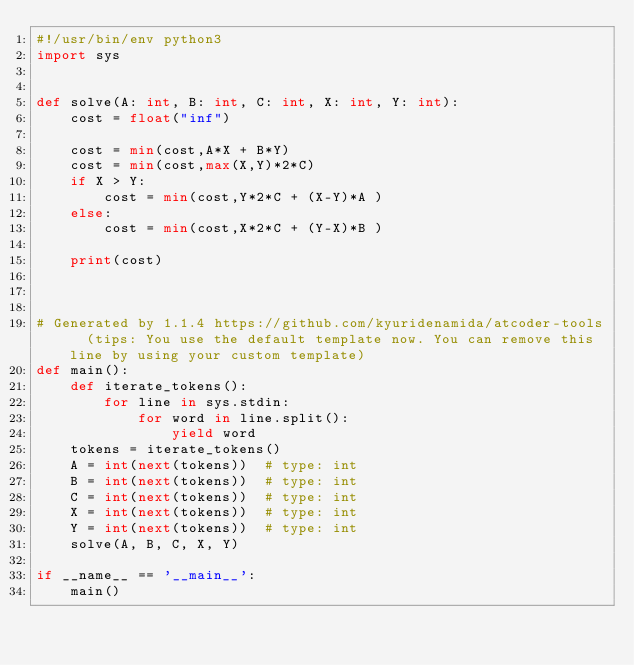<code> <loc_0><loc_0><loc_500><loc_500><_Python_>#!/usr/bin/env python3
import sys


def solve(A: int, B: int, C: int, X: int, Y: int):
    cost = float("inf")

    cost = min(cost,A*X + B*Y)
    cost = min(cost,max(X,Y)*2*C)
    if X > Y:
        cost = min(cost,Y*2*C + (X-Y)*A )
    else:
        cost = min(cost,X*2*C + (Y-X)*B )

    print(cost)



# Generated by 1.1.4 https://github.com/kyuridenamida/atcoder-tools  (tips: You use the default template now. You can remove this line by using your custom template)
def main():
    def iterate_tokens():
        for line in sys.stdin:
            for word in line.split():
                yield word
    tokens = iterate_tokens()
    A = int(next(tokens))  # type: int
    B = int(next(tokens))  # type: int
    C = int(next(tokens))  # type: int
    X = int(next(tokens))  # type: int
    Y = int(next(tokens))  # type: int
    solve(A, B, C, X, Y)

if __name__ == '__main__':
    main()
</code> 